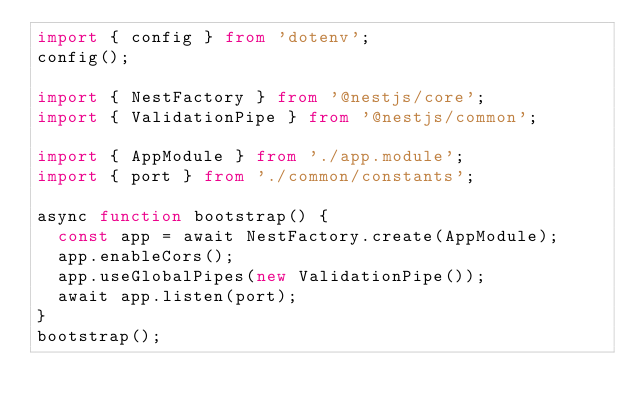Convert code to text. <code><loc_0><loc_0><loc_500><loc_500><_TypeScript_>import { config } from 'dotenv';
config();

import { NestFactory } from '@nestjs/core';
import { ValidationPipe } from '@nestjs/common';

import { AppModule } from './app.module';
import { port } from './common/constants';

async function bootstrap() {
  const app = await NestFactory.create(AppModule);
  app.enableCors();
  app.useGlobalPipes(new ValidationPipe());
  await app.listen(port);
}
bootstrap();
</code> 